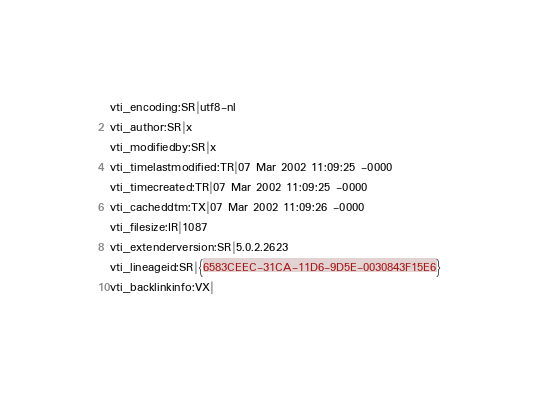Convert code to text. <code><loc_0><loc_0><loc_500><loc_500><_CSS_>vti_encoding:SR|utf8-nl
vti_author:SR|x
vti_modifiedby:SR|x
vti_timelastmodified:TR|07 Mar 2002 11:09:25 -0000
vti_timecreated:TR|07 Mar 2002 11:09:25 -0000
vti_cacheddtm:TX|07 Mar 2002 11:09:26 -0000
vti_filesize:IR|1087
vti_extenderversion:SR|5.0.2.2623
vti_lineageid:SR|{6583CEEC-31CA-11D6-9D5E-0030843F15E6}
vti_backlinkinfo:VX|
</code> 